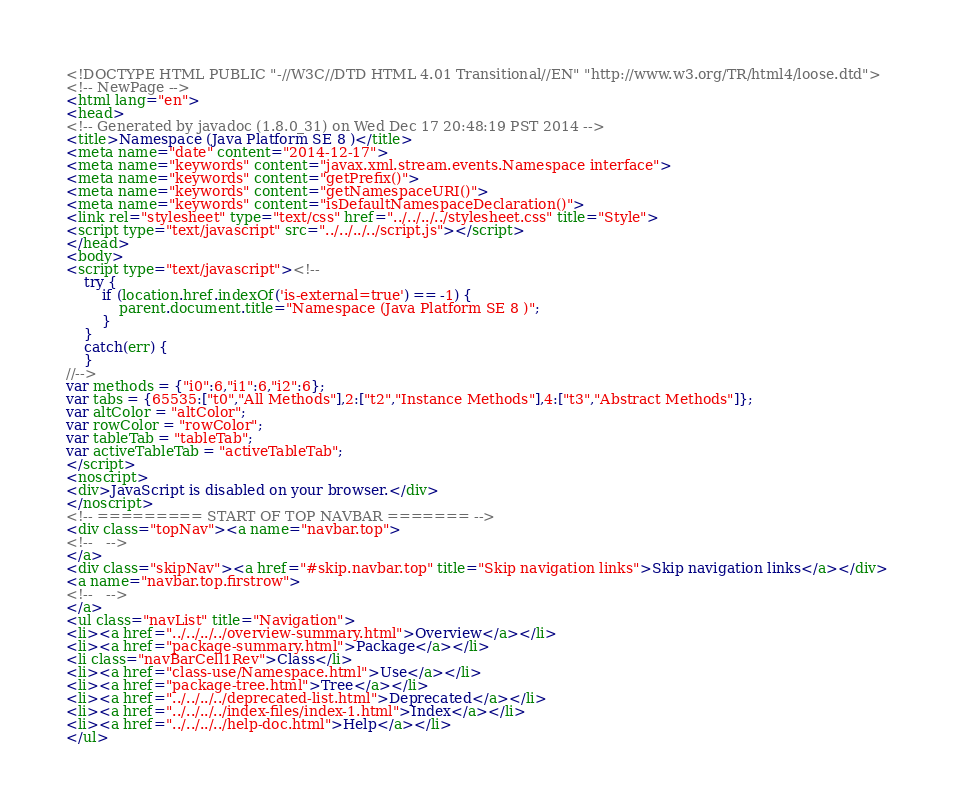<code> <loc_0><loc_0><loc_500><loc_500><_HTML_><!DOCTYPE HTML PUBLIC "-//W3C//DTD HTML 4.01 Transitional//EN" "http://www.w3.org/TR/html4/loose.dtd">
<!-- NewPage -->
<html lang="en">
<head>
<!-- Generated by javadoc (1.8.0_31) on Wed Dec 17 20:48:19 PST 2014 -->
<title>Namespace (Java Platform SE 8 )</title>
<meta name="date" content="2014-12-17">
<meta name="keywords" content="javax.xml.stream.events.Namespace interface">
<meta name="keywords" content="getPrefix()">
<meta name="keywords" content="getNamespaceURI()">
<meta name="keywords" content="isDefaultNamespaceDeclaration()">
<link rel="stylesheet" type="text/css" href="../../../../stylesheet.css" title="Style">
<script type="text/javascript" src="../../../../script.js"></script>
</head>
<body>
<script type="text/javascript"><!--
    try {
        if (location.href.indexOf('is-external=true') == -1) {
            parent.document.title="Namespace (Java Platform SE 8 )";
        }
    }
    catch(err) {
    }
//-->
var methods = {"i0":6,"i1":6,"i2":6};
var tabs = {65535:["t0","All Methods"],2:["t2","Instance Methods"],4:["t3","Abstract Methods"]};
var altColor = "altColor";
var rowColor = "rowColor";
var tableTab = "tableTab";
var activeTableTab = "activeTableTab";
</script>
<noscript>
<div>JavaScript is disabled on your browser.</div>
</noscript>
<!-- ========= START OF TOP NAVBAR ======= -->
<div class="topNav"><a name="navbar.top">
<!--   -->
</a>
<div class="skipNav"><a href="#skip.navbar.top" title="Skip navigation links">Skip navigation links</a></div>
<a name="navbar.top.firstrow">
<!--   -->
</a>
<ul class="navList" title="Navigation">
<li><a href="../../../../overview-summary.html">Overview</a></li>
<li><a href="package-summary.html">Package</a></li>
<li class="navBarCell1Rev">Class</li>
<li><a href="class-use/Namespace.html">Use</a></li>
<li><a href="package-tree.html">Tree</a></li>
<li><a href="../../../../deprecated-list.html">Deprecated</a></li>
<li><a href="../../../../index-files/index-1.html">Index</a></li>
<li><a href="../../../../help-doc.html">Help</a></li>
</ul></code> 